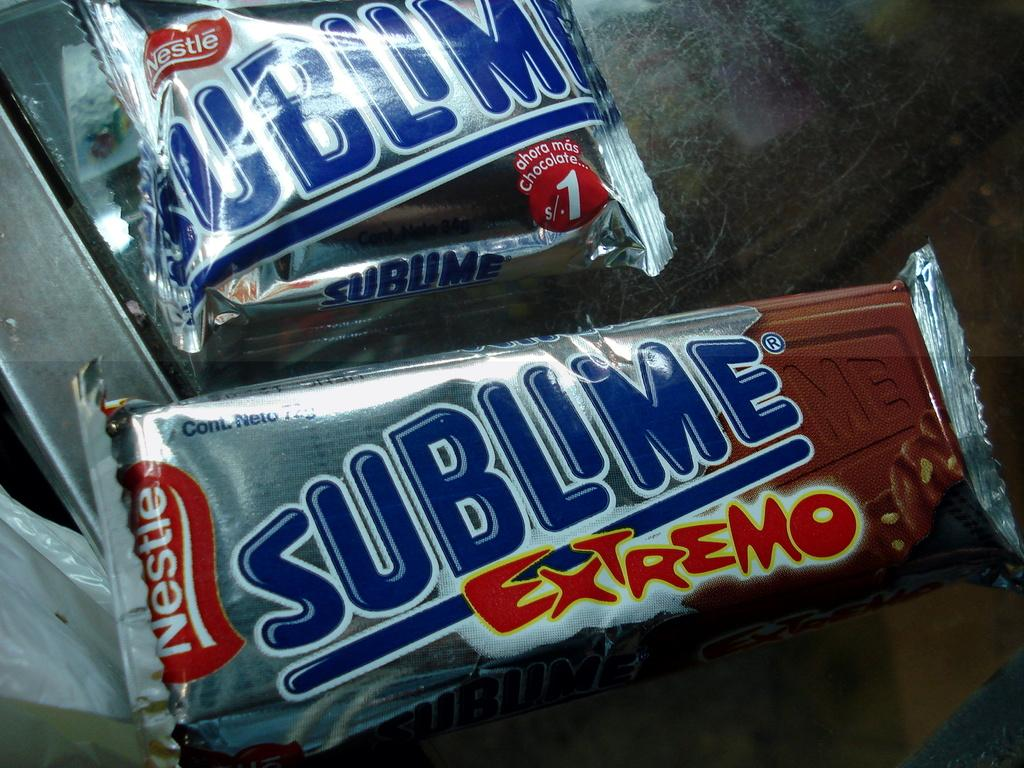Provide a one-sentence caption for the provided image. A couple of Nestle ice cream treats promise extreme deliciousness. 